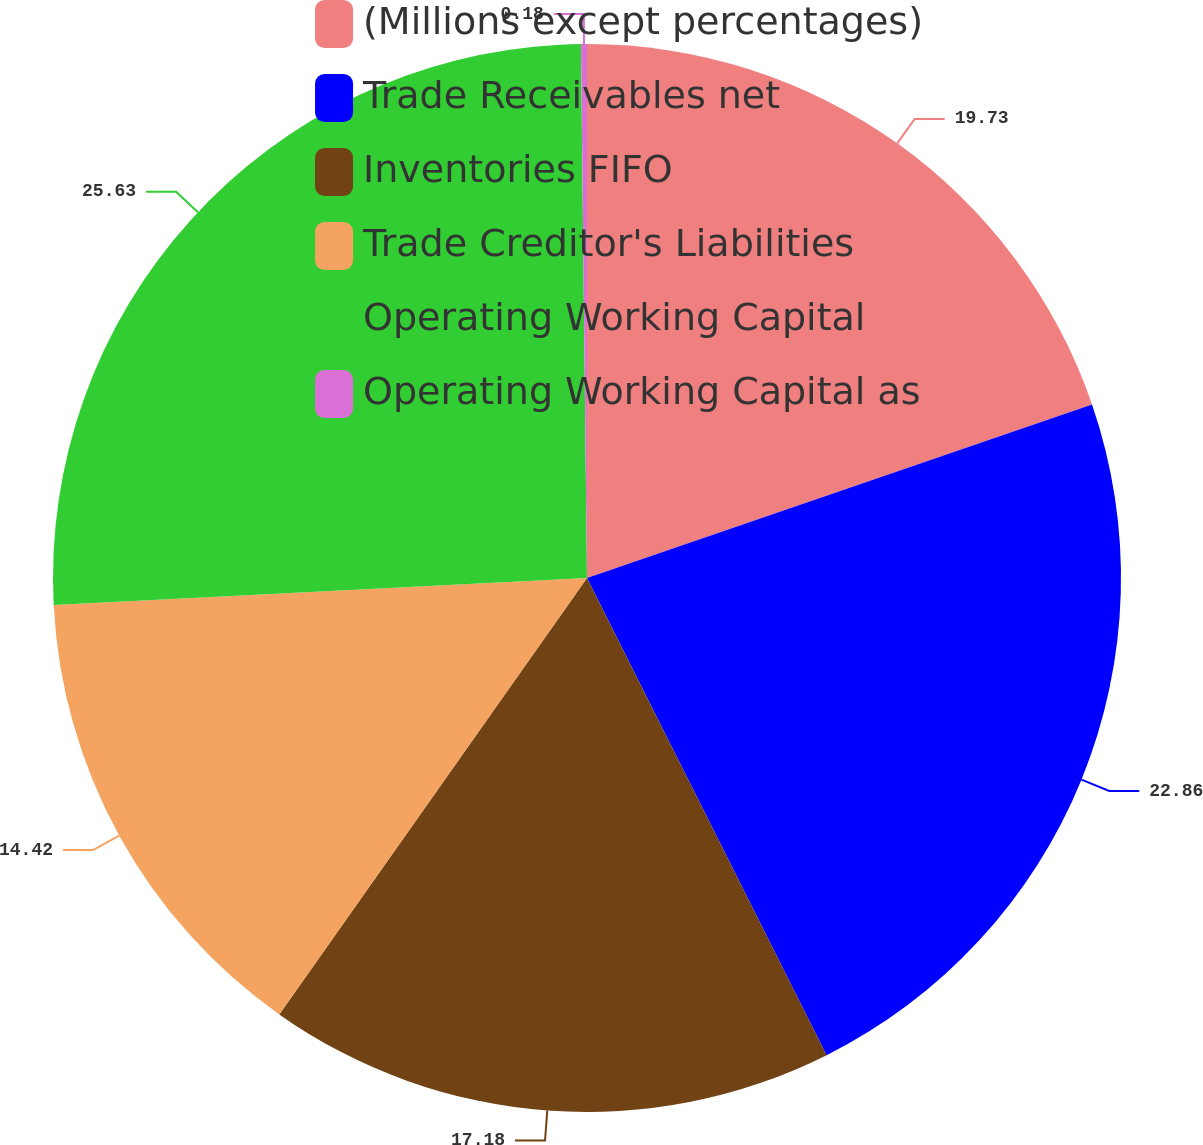Convert chart to OTSL. <chart><loc_0><loc_0><loc_500><loc_500><pie_chart><fcel>(Millions except percentages)<fcel>Trade Receivables net<fcel>Inventories FIFO<fcel>Trade Creditor's Liabilities<fcel>Operating Working Capital<fcel>Operating Working Capital as<nl><fcel>19.73%<fcel>22.86%<fcel>17.18%<fcel>14.42%<fcel>25.62%<fcel>0.18%<nl></chart> 